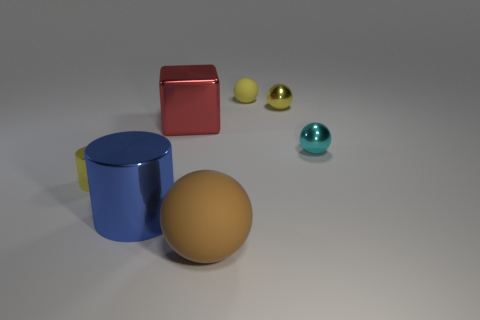The small matte thing has what color?
Your response must be concise. Yellow. Is the shape of the yellow shiny thing that is on the right side of the big shiny cylinder the same as  the large blue metal thing?
Your response must be concise. No. How many things are large cyan metal blocks or small yellow objects to the right of the big brown rubber thing?
Offer a terse response. 2. Do the small object that is on the left side of the big brown matte ball and the blue thing have the same material?
Make the answer very short. Yes. Is there anything else that has the same size as the brown thing?
Provide a succinct answer. Yes. The yellow object to the left of the large shiny object in front of the cyan object is made of what material?
Offer a terse response. Metal. Is the number of brown matte things on the left side of the big brown rubber sphere greater than the number of small yellow rubber balls that are in front of the small cylinder?
Ensure brevity in your answer.  No. The brown matte ball is what size?
Give a very brief answer. Large. Does the tiny metal object behind the red block have the same color as the metal cube?
Make the answer very short. No. Is there anything else that has the same shape as the big blue object?
Your response must be concise. Yes. 